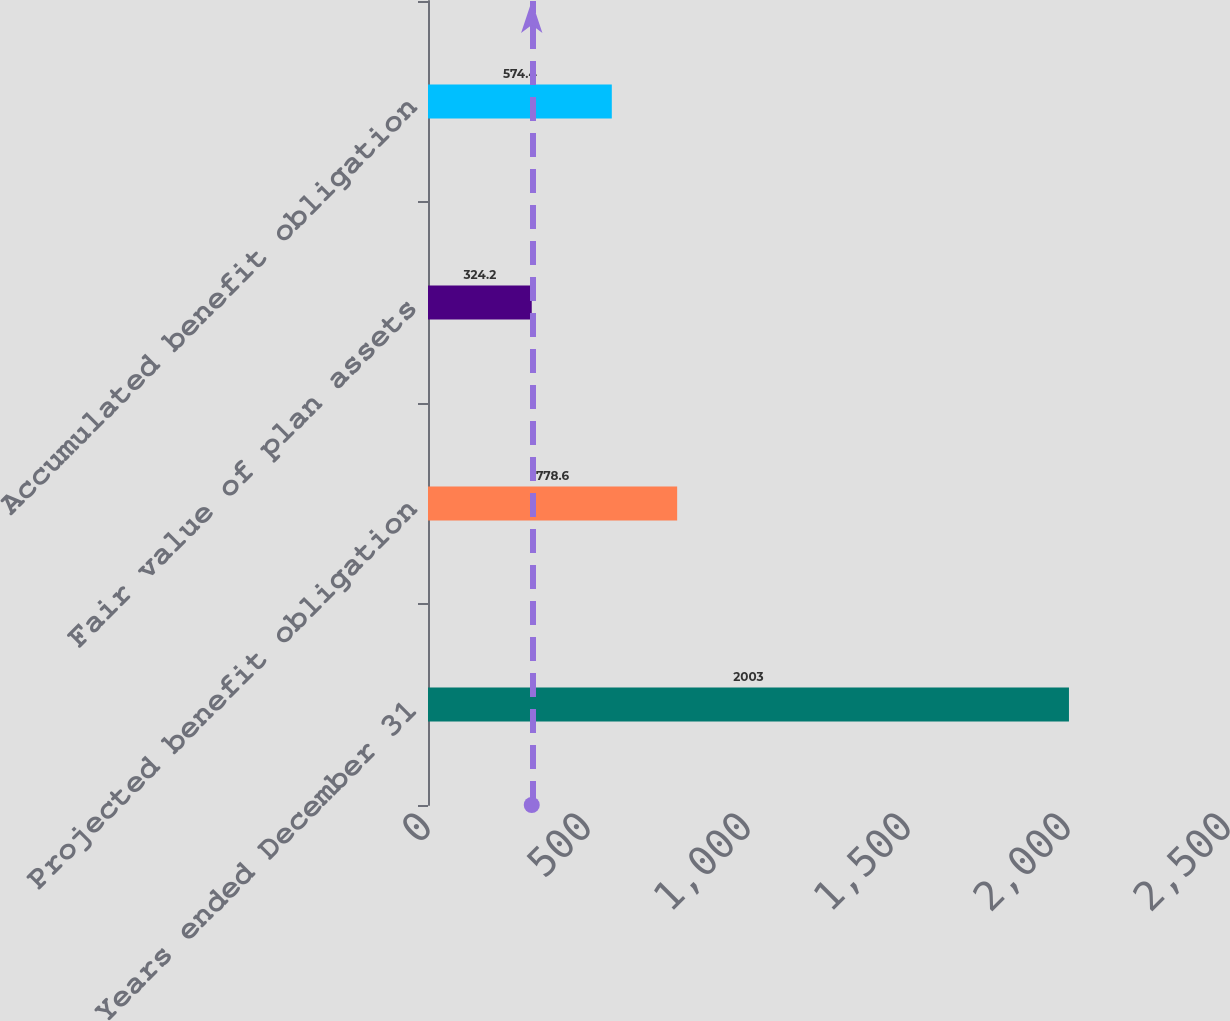<chart> <loc_0><loc_0><loc_500><loc_500><bar_chart><fcel>Years ended December 31<fcel>Projected benefit obligation<fcel>Fair value of plan assets<fcel>Accumulated benefit obligation<nl><fcel>2003<fcel>778.6<fcel>324.2<fcel>574.4<nl></chart> 